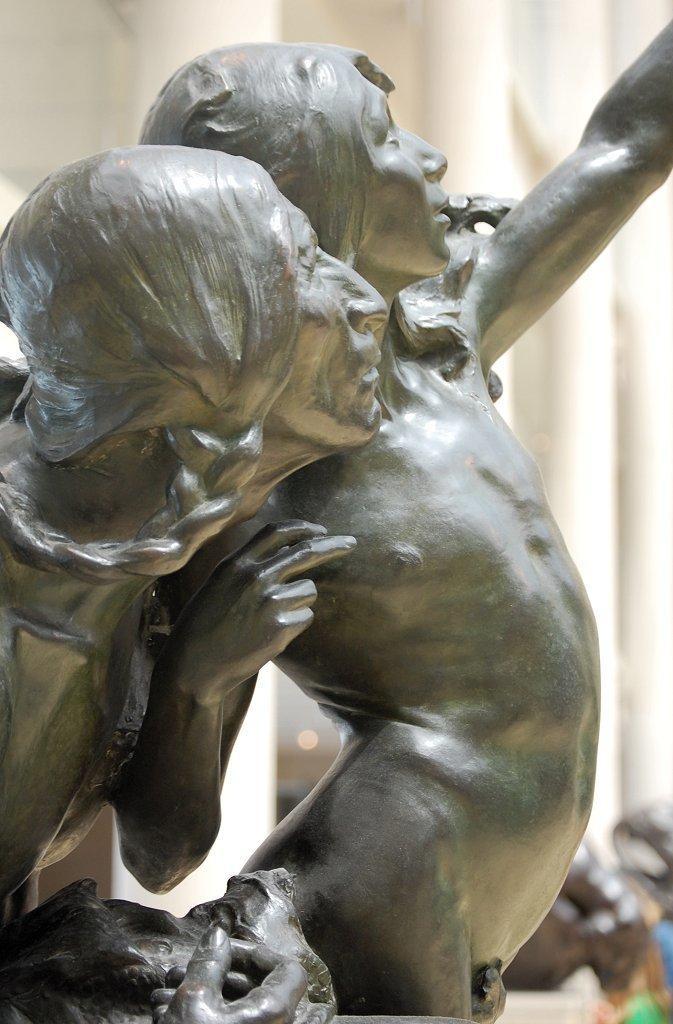Please provide a concise description of this image. In this image, we can see statues and in the background, there is wall. 